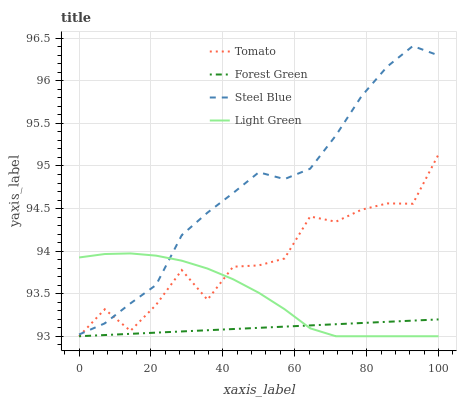Does Forest Green have the minimum area under the curve?
Answer yes or no. Yes. Does Steel Blue have the maximum area under the curve?
Answer yes or no. Yes. Does Steel Blue have the minimum area under the curve?
Answer yes or no. No. Does Forest Green have the maximum area under the curve?
Answer yes or no. No. Is Forest Green the smoothest?
Answer yes or no. Yes. Is Tomato the roughest?
Answer yes or no. Yes. Is Steel Blue the smoothest?
Answer yes or no. No. Is Steel Blue the roughest?
Answer yes or no. No. Does Tomato have the lowest value?
Answer yes or no. Yes. Does Steel Blue have the lowest value?
Answer yes or no. No. Does Steel Blue have the highest value?
Answer yes or no. Yes. Does Forest Green have the highest value?
Answer yes or no. No. Is Forest Green less than Steel Blue?
Answer yes or no. Yes. Is Steel Blue greater than Forest Green?
Answer yes or no. Yes. Does Tomato intersect Steel Blue?
Answer yes or no. Yes. Is Tomato less than Steel Blue?
Answer yes or no. No. Is Tomato greater than Steel Blue?
Answer yes or no. No. Does Forest Green intersect Steel Blue?
Answer yes or no. No. 